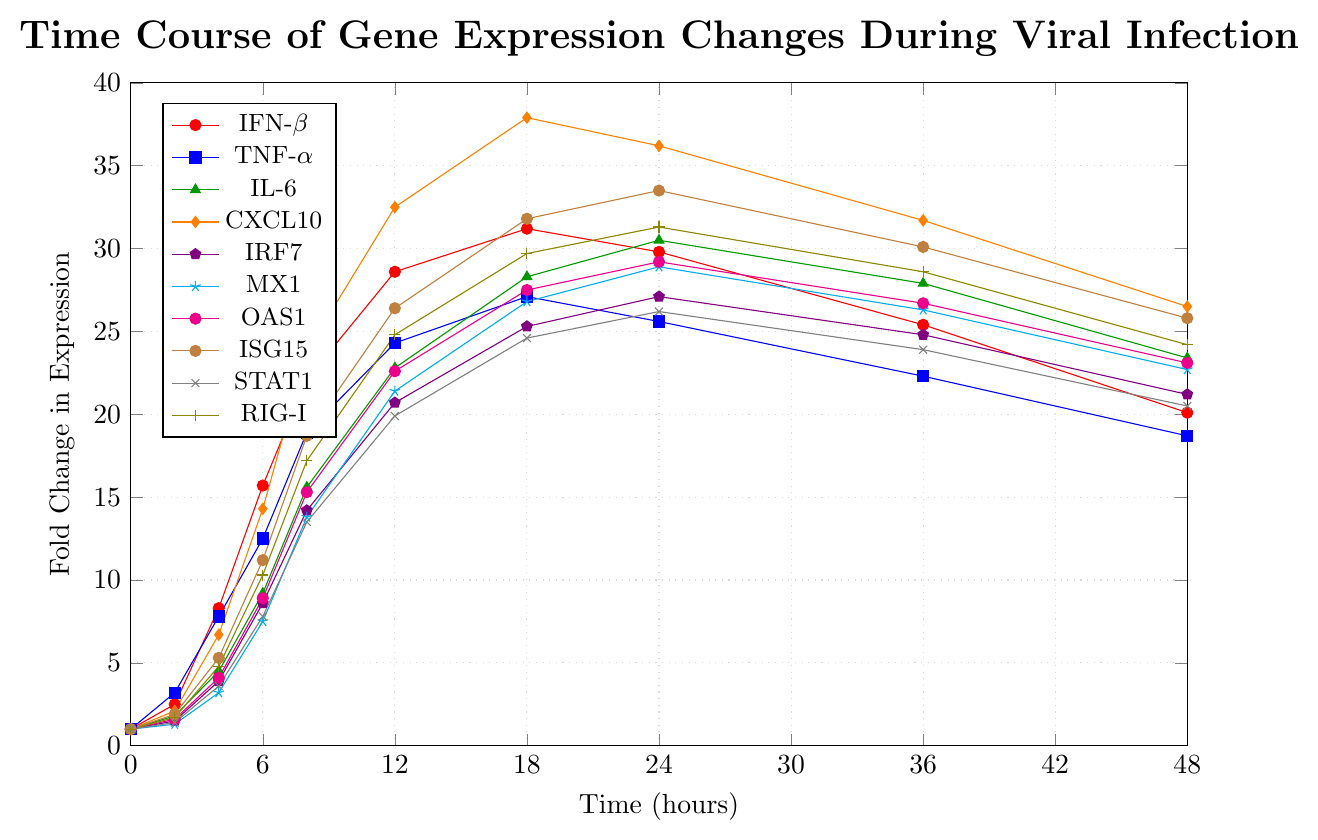Which gene shows the highest fold change in expression at the 18-hour mark? At the 18-hour mark, CXCL10 reaches the highest expression level at 37.9, more than other genes.
Answer: CXCL10 Which gene has the steepest increase in expression between 2 and 12 hours? By examining the slopes between 2 and 12 hours, CXCL10 has the steepest rise, going from 2.1 to 32.5.
Answer: CXCL10 What is the average expression fold change of IFN-β over the entire time course? Summing up the fold change values of IFN-β: (1 + 2.5 + 8.3 + 15.7 + 22.1 + 28.6 + 31.2 + 29.8 + 25.4 + 20.1) = 184.7, then dividing by the number of time points, 10, gives the average: 184.7 / 10 = 18.47
Answer: 18.47 Which gene has the smallest change in expression from 0 to 48 hours? Comparing the fold changes from 0 to 48 hours, MX1 changes from 1 to 22.7, the smallest difference among the genes.
Answer: MX1 At what time point does RIG-I reach its peak expression? By checking the figure, RIG-I reaches its highest fold change value, 31.3, at 24 hours.
Answer: 24 hours Compare the expression of IL-6 and TNF-α at 12 hours and determine which is higher. At 12 hours, IL-6 is at 22.8 fold change while TNF-α is at 24.3 fold change, making TNF-α slightly higher.
Answer: TNF-α Which gene has the most consistent increase in expression over time? Analyzing the trends, CXCL10 consistently increases in expression without significant dips, showing a smooth upward trend up to 24 hours.
Answer: CXCL10 What is the relative difference in fold change between STAT1 and IRF7 at 48 hours? At 48 hours, STAT1 is at 20.5 while IRF7 is at 21.2. The difference is 21.2 - 20.5 = 0.7.
Answer: 0.7 How much greater is the fold change of ISG15 compared to MX1 at 36 hours? At 36 hours, ISG15 is at 30.1 and MX1 is at 26.3. The difference is 30.1 - 26.3 = 3.8.
Answer: 3.8 During which time interval does OAS1 experience the largest increase in expression? By comparing the intervals, from 6 to 12 hours, OAS1 increases from 8.9 to 22.6, the largest increase of 13.7.
Answer: 6 to 12 hours 